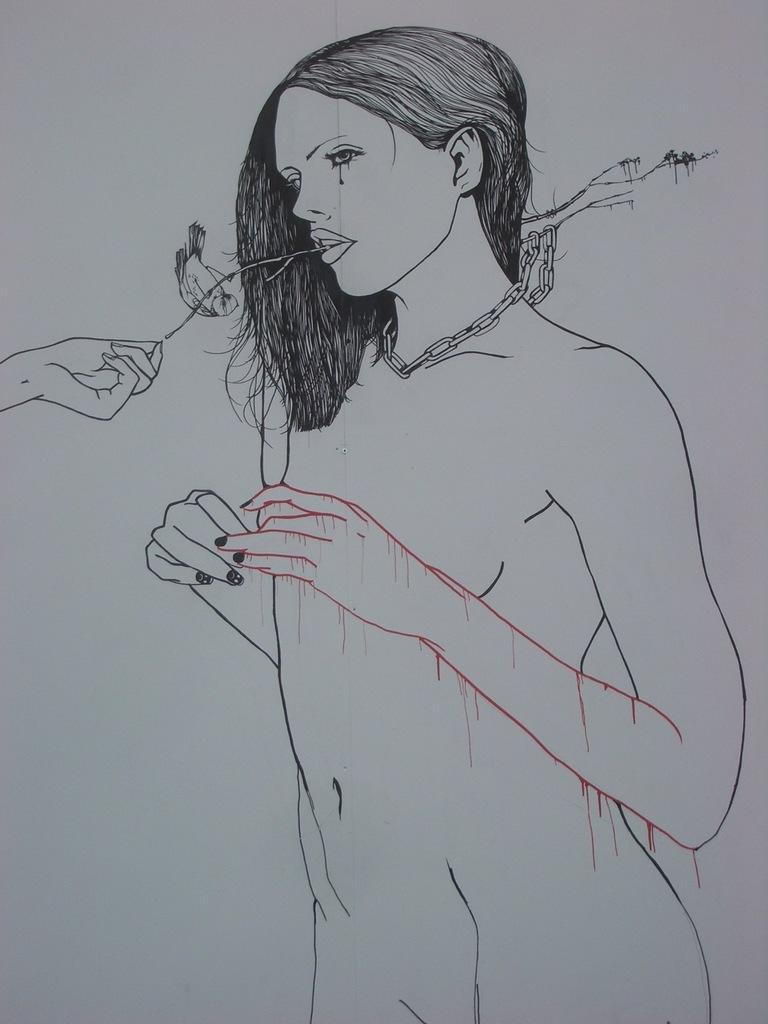Describe this image in one or two sentences. In this image, we can see the pencil sketch of a woman in the white paper. 